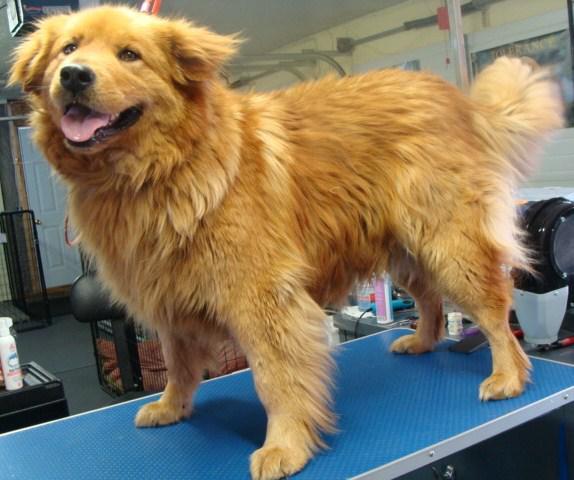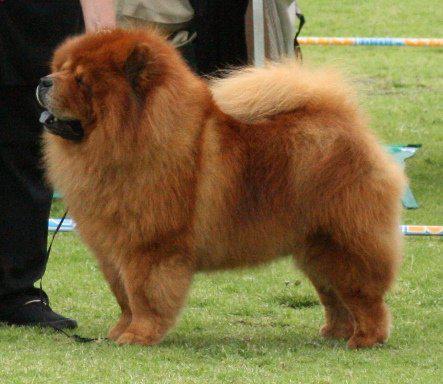The first image is the image on the left, the second image is the image on the right. For the images shown, is this caption "The dog in the right image is attached to a purple leash." true? Answer yes or no. No. The first image is the image on the left, the second image is the image on the right. Examine the images to the left and right. Is the description "Right image shows a standing chow dog, and left image shows a different breed of dog standing." accurate? Answer yes or no. Yes. 